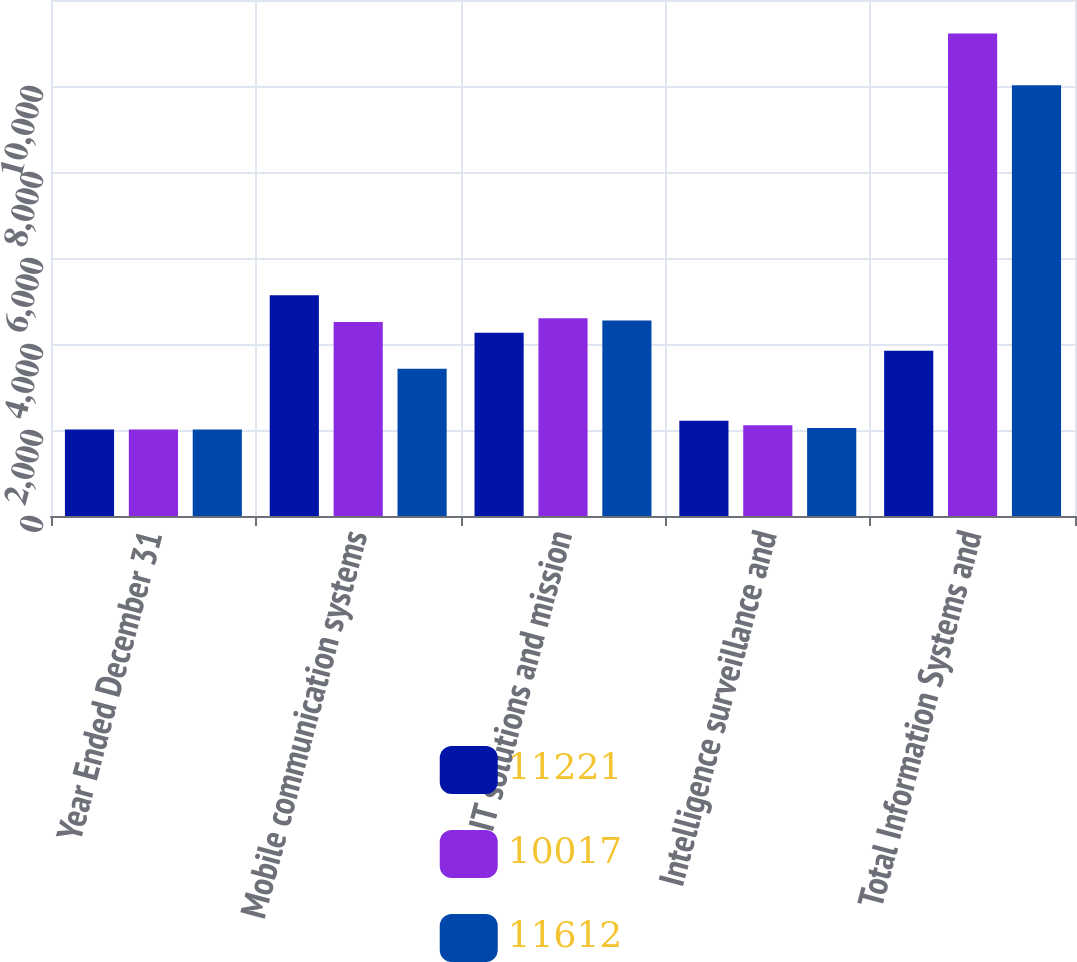Convert chart. <chart><loc_0><loc_0><loc_500><loc_500><stacked_bar_chart><ecel><fcel>Year Ended December 31<fcel>Mobile communication systems<fcel>IT solutions and mission<fcel>Intelligence surveillance and<fcel>Total Information Systems and<nl><fcel>11221<fcel>2010<fcel>5134<fcel>4262<fcel>2216<fcel>3843.5<nl><fcel>10017<fcel>2011<fcel>4511<fcel>4601<fcel>2109<fcel>11221<nl><fcel>11612<fcel>2012<fcel>3425<fcel>4545<fcel>2047<fcel>10017<nl></chart> 